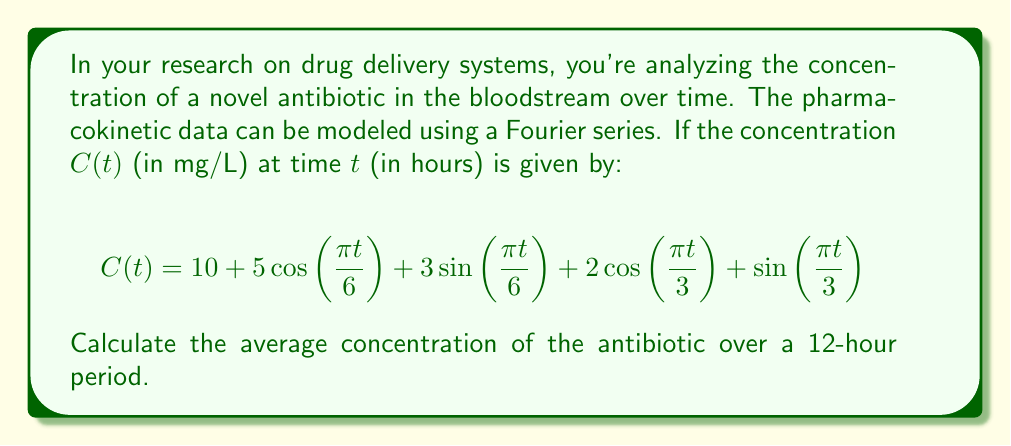Show me your answer to this math problem. To find the average concentration over a 12-hour period, we need to integrate the function $C(t)$ over the interval $[0, 12]$ and divide by the length of the interval. The average is given by:

$$\text{Average} = \frac{1}{12}\int_0^{12} C(t) dt$$

Let's integrate each term of the Fourier series:

1) For the constant term: $\int_0^{12} 10 dt = 10t\big|_0^{12} = 120$

2) For $5\cos(\frac{\pi t}{6})$:
   $$\int_0^{12} 5\cos(\frac{\pi t}{6}) dt = \frac{30}{\pi}\sin(\frac{\pi t}{6})\big|_0^{12} = \frac{30}{\pi}[\sin(2\pi) - \sin(0)] = 0$$

3) For $3\sin(\frac{\pi t}{6})$:
   $$\int_0^{12} 3\sin(\frac{\pi t}{6}) dt = -\frac{18}{\pi}\cos(\frac{\pi t}{6})\big|_0^{12} = -\frac{18}{\pi}[\cos(2\pi) - \cos(0)] = 0$$

4) For $2\cos(\frac{\pi t}{3})$:
   $$\int_0^{12} 2\cos(\frac{\pi t}{3}) dt = \frac{6}{\pi}\sin(\frac{\pi t}{3})\big|_0^{12} = \frac{6}{\pi}[\sin(4\pi) - \sin(0)] = 0$$

5) For $\sin(\frac{\pi t}{3})$:
   $$\int_0^{12} \sin(\frac{\pi t}{3}) dt = -\frac{3}{\pi}\cos(\frac{\pi t}{3})\big|_0^{12} = -\frac{3}{\pi}[\cos(4\pi) - \cos(0)] = 0$$

The sum of all these integrals is 120. Dividing by the interval length:

$$\text{Average} = \frac{1}{12} \cdot 120 = 10 \text{ mg/L}$$
Answer: 10 mg/L 